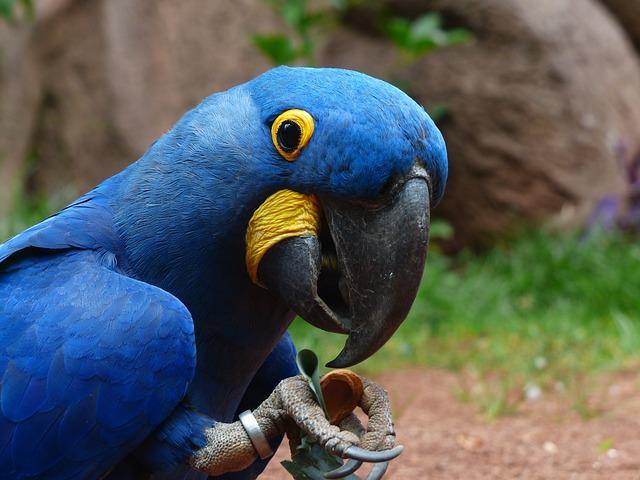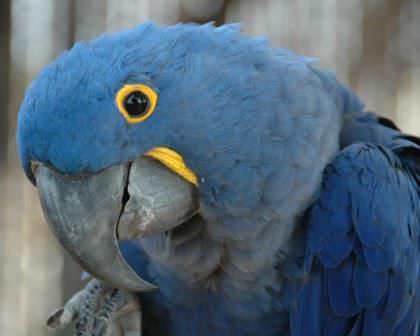The first image is the image on the left, the second image is the image on the right. Assess this claim about the two images: "There is exactly one bird in the image on the right.". Correct or not? Answer yes or no. Yes. 